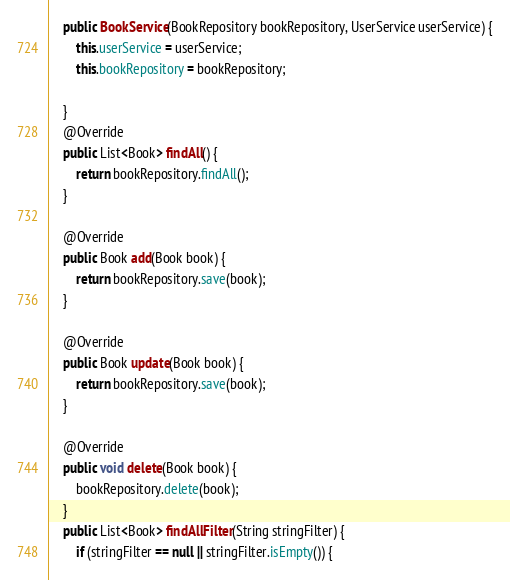Convert code to text. <code><loc_0><loc_0><loc_500><loc_500><_Java_>    public BookService(BookRepository bookRepository, UserService userService) {
        this.userService = userService;
        this.bookRepository = bookRepository;

    }
    @Override
    public List<Book> findAll() {
        return bookRepository.findAll();
    }

    @Override
    public Book add(Book book) {
        return bookRepository.save(book);
    }

    @Override
    public Book update(Book book) {
        return bookRepository.save(book);
    }

    @Override
    public void delete(Book book) {
        bookRepository.delete(book);
    }
    public List<Book> findAllFilter(String stringFilter) {
        if (stringFilter == null || stringFilter.isEmpty()) {</code> 